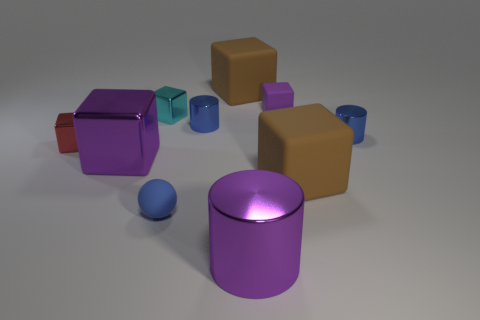Subtract all large purple metallic cylinders. How many cylinders are left? 2 Subtract all brown cubes. How many blue cylinders are left? 2 Subtract all brown cubes. How many cubes are left? 4 Subtract all cubes. How many objects are left? 4 Subtract all red cylinders. Subtract all blue balls. How many cylinders are left? 3 Subtract all spheres. Subtract all big gray matte cylinders. How many objects are left? 9 Add 5 metallic cubes. How many metallic cubes are left? 8 Add 4 large blocks. How many large blocks exist? 7 Subtract 0 red cylinders. How many objects are left? 10 